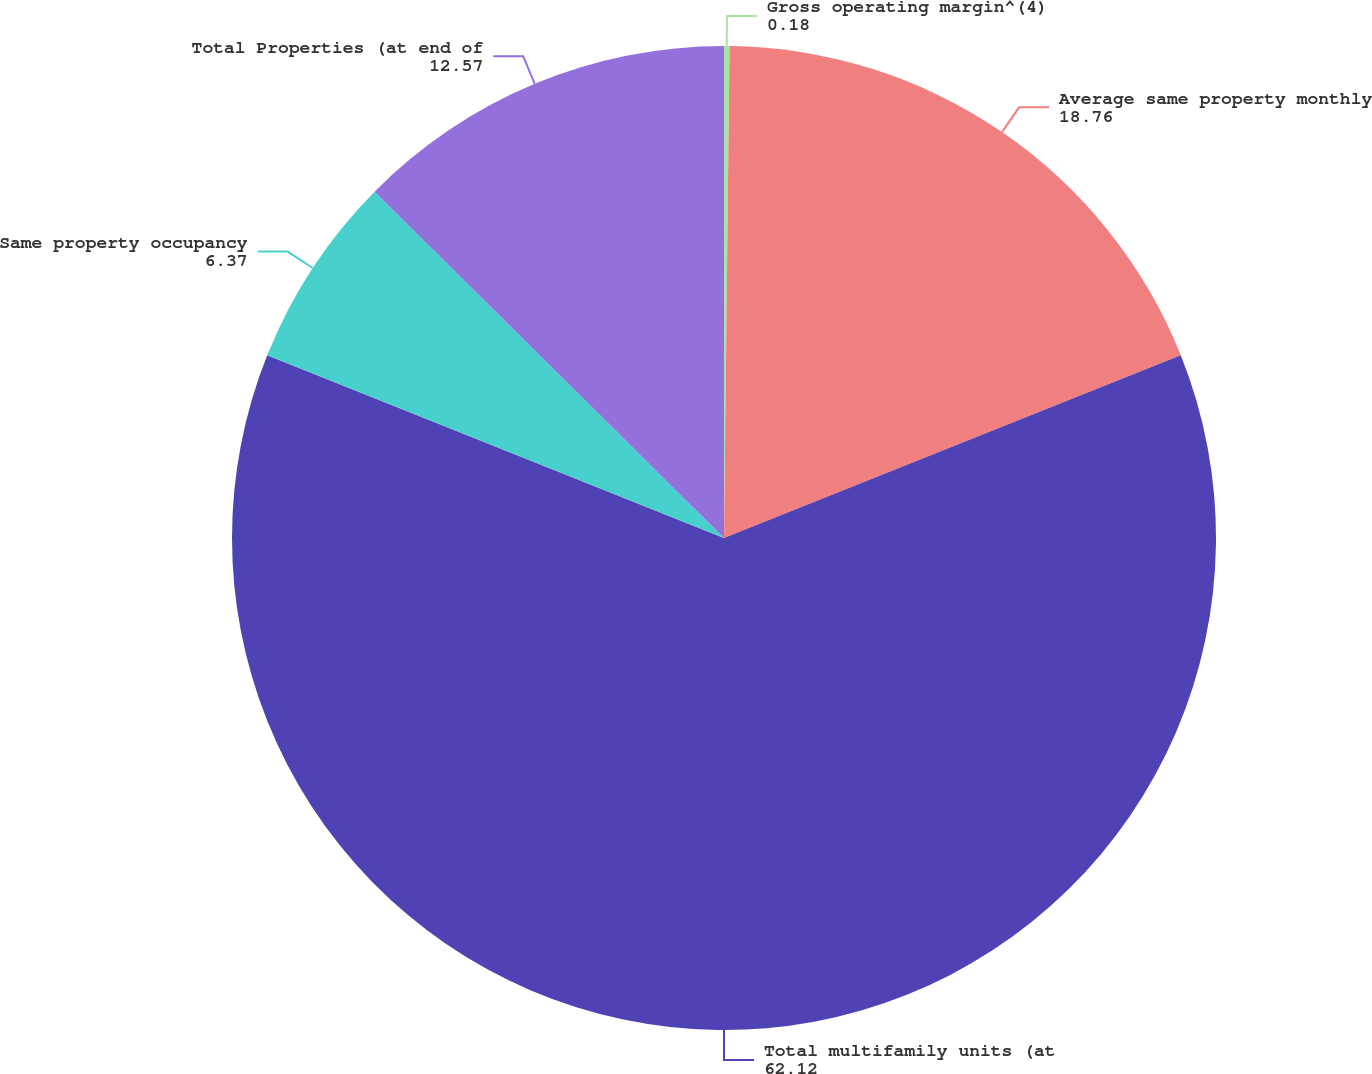Convert chart. <chart><loc_0><loc_0><loc_500><loc_500><pie_chart><fcel>Gross operating margin^(4)<fcel>Average same property monthly<fcel>Total multifamily units (at<fcel>Same property occupancy<fcel>Total Properties (at end of<nl><fcel>0.18%<fcel>18.76%<fcel>62.12%<fcel>6.37%<fcel>12.57%<nl></chart> 